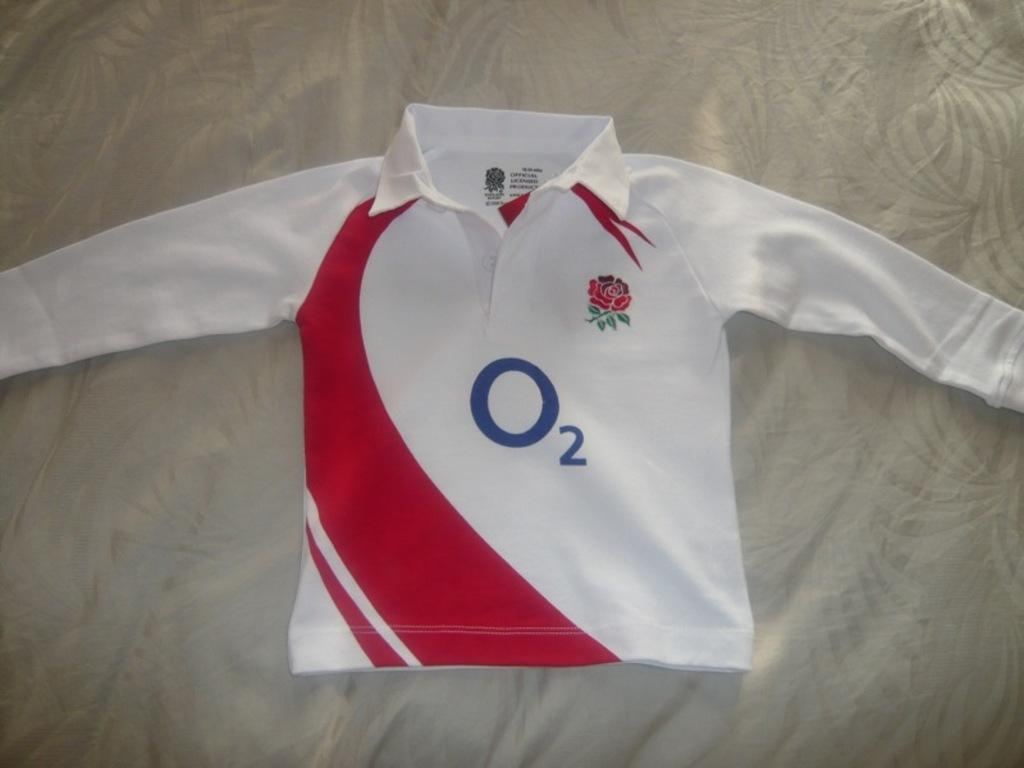<image>
Describe the image concisely. A child's long-sleeved white O2 England shirt, with red swooshing symbol up the left side, is laid out on a bed. 